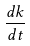<formula> <loc_0><loc_0><loc_500><loc_500>\frac { d k } { d t }</formula> 